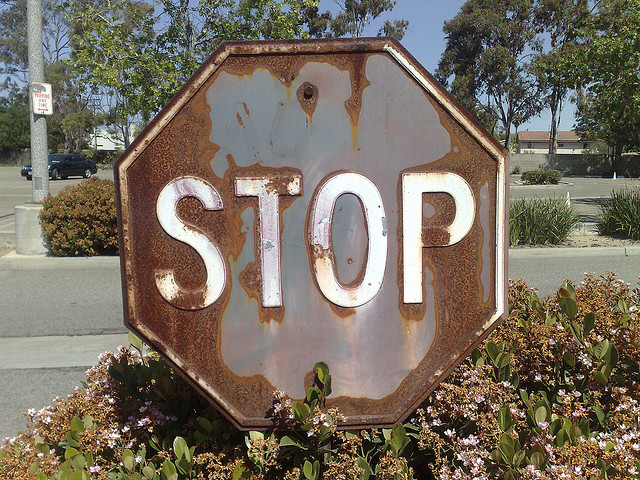Identify the text displayed in this image. STOP 